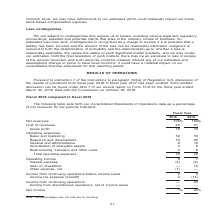According to Nortonlifelock's financial document, What does the table show? Consolidated Statements of Operations data as a percentage of net revenues for the periods indicated. The document states: "The following table sets forth our Consolidated Statements of Operations data as a percentage of net revenues for the periods indicated:..." Also, What are the fiscal year periods indicated in the table? The document shows two values: Fiscal 2019 and Fiscal 2018. From the document: "Fiscal 2019 compared to fiscal 2018 Fiscal 2019 compared to fiscal 2018..." Also, What is the cost of revenue percentage for fiscal year 2019? According to the financial document, 22 (percentage). The relevant text states: "Net revenues 100% 100% Cost of revenues 22 21..." Also, can you calculate: What is the change in cost of revenues relative to Net revenue from fiscal year 2018 to fiscal year 2019? Based on the calculation: 22-21, the result is 1 (percentage). This is based on the information: "Net revenues 100% 100% Cost of revenues 22 21 Net revenues 100% 100% Cost of revenues 22 21..." The key data points involved are: 21, 22. Also, can you calculate: What is the Sales and marketing costs expressed as a percentage of Total operating expenses in 2019? Based on the calculation: 32/70, the result is 45.71 (percentage). This is based on the information: "Total operating expenses 70 78 fit 78 79 Operating expenses: Sales and marketing 32 33 Research and development 19 20 General and administrative 9 12 Amortization of intangible assets..." The key data points involved are: 32, 70. Also, can you calculate: What is the change in Total operating expenses from fiscal year 2018 to fiscal year 2019? Based on the calculation: 70-78, the result is -8 (percentage). This is based on the information: "Total operating expenses 70 78 Total operating expenses 70 78..." The key data points involved are: 70, 78. 